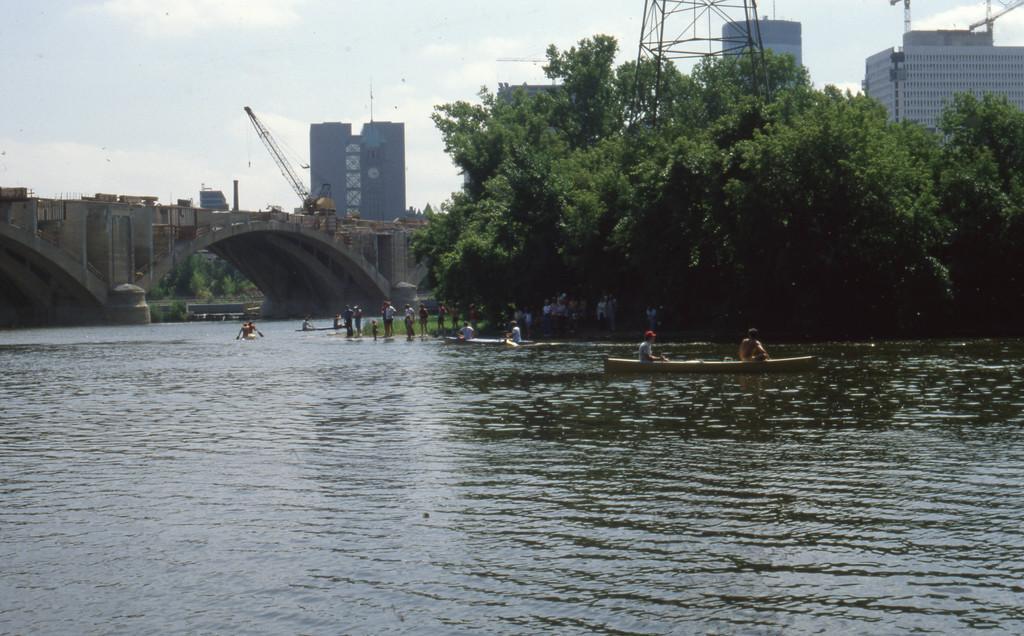Describe this image in one or two sentences. In this image I can see it looks like the river and few boats are there in it. In the middle few people are standing on the land. On the right side there are trees, behind these trees there are buildings. On the left side it is the bridge, at the top it is the cloudy sky. 